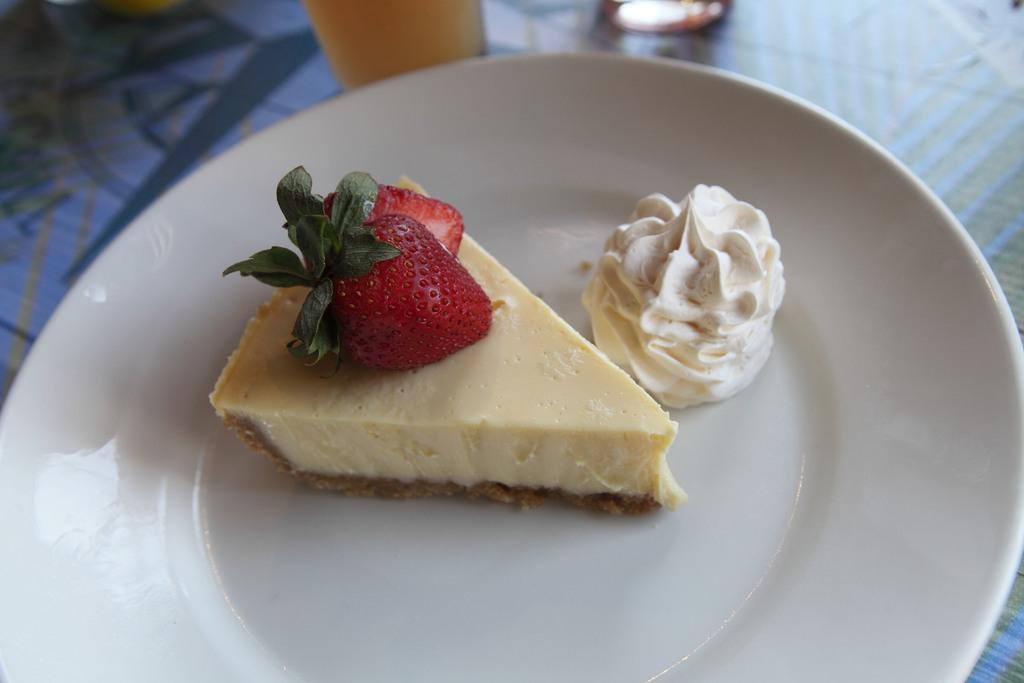Describe this image in one or two sentences. In this image we can see the food items in the plate and the plate is placed on the table. In the background we can see the glass. 